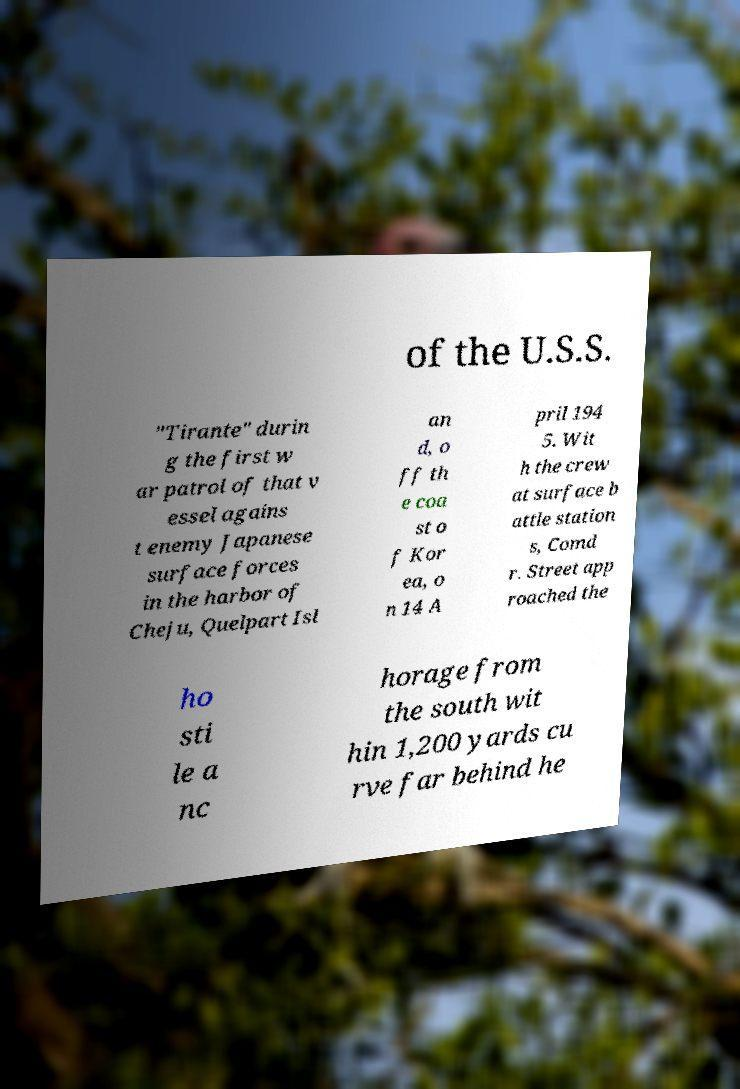For documentation purposes, I need the text within this image transcribed. Could you provide that? of the U.S.S. "Tirante" durin g the first w ar patrol of that v essel agains t enemy Japanese surface forces in the harbor of Cheju, Quelpart Isl an d, o ff th e coa st o f Kor ea, o n 14 A pril 194 5. Wit h the crew at surface b attle station s, Comd r. Street app roached the ho sti le a nc horage from the south wit hin 1,200 yards cu rve far behind he 